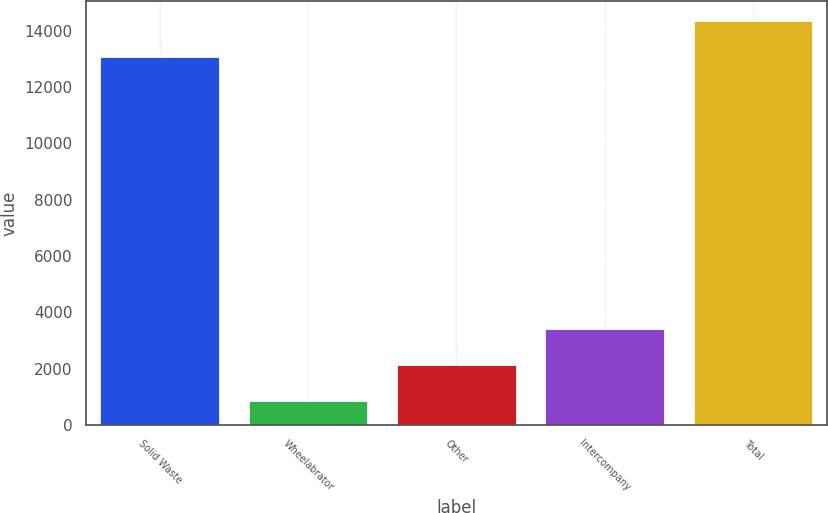<chart> <loc_0><loc_0><loc_500><loc_500><bar_chart><fcel>Solid Waste<fcel>Wheelabrator<fcel>Other<fcel>Intercompany<fcel>Total<nl><fcel>13056<fcel>846<fcel>2126.3<fcel>3406.6<fcel>14336.3<nl></chart> 